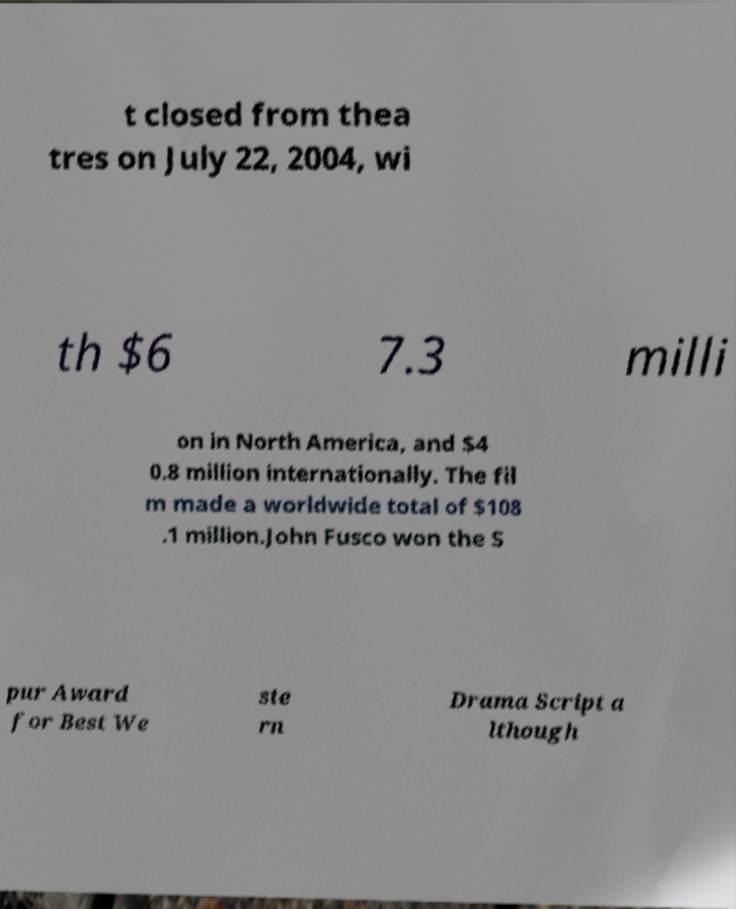For documentation purposes, I need the text within this image transcribed. Could you provide that? t closed from thea tres on July 22, 2004, wi th $6 7.3 milli on in North America, and $4 0.8 million internationally. The fil m made a worldwide total of $108 .1 million.John Fusco won the S pur Award for Best We ste rn Drama Script a lthough 